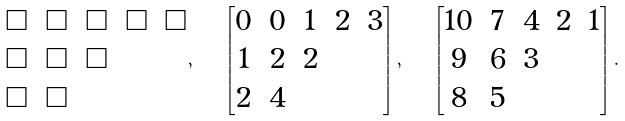Convert formula to latex. <formula><loc_0><loc_0><loc_500><loc_500>\begin{matrix} \square & \square & \square & \square & \square \\ \square & \square & \square & & \\ \square & \square & & & \end{matrix} , \quad \begin{bmatrix} 0 & 0 & 1 & 2 & 3 \\ 1 & 2 & 2 & & \\ 2 & 4 & & & \end{bmatrix} , \quad \begin{bmatrix} 1 0 & 7 & 4 & 2 & 1 \\ 9 & 6 & 3 & & \\ 8 & 5 & & & \end{bmatrix} .</formula> 